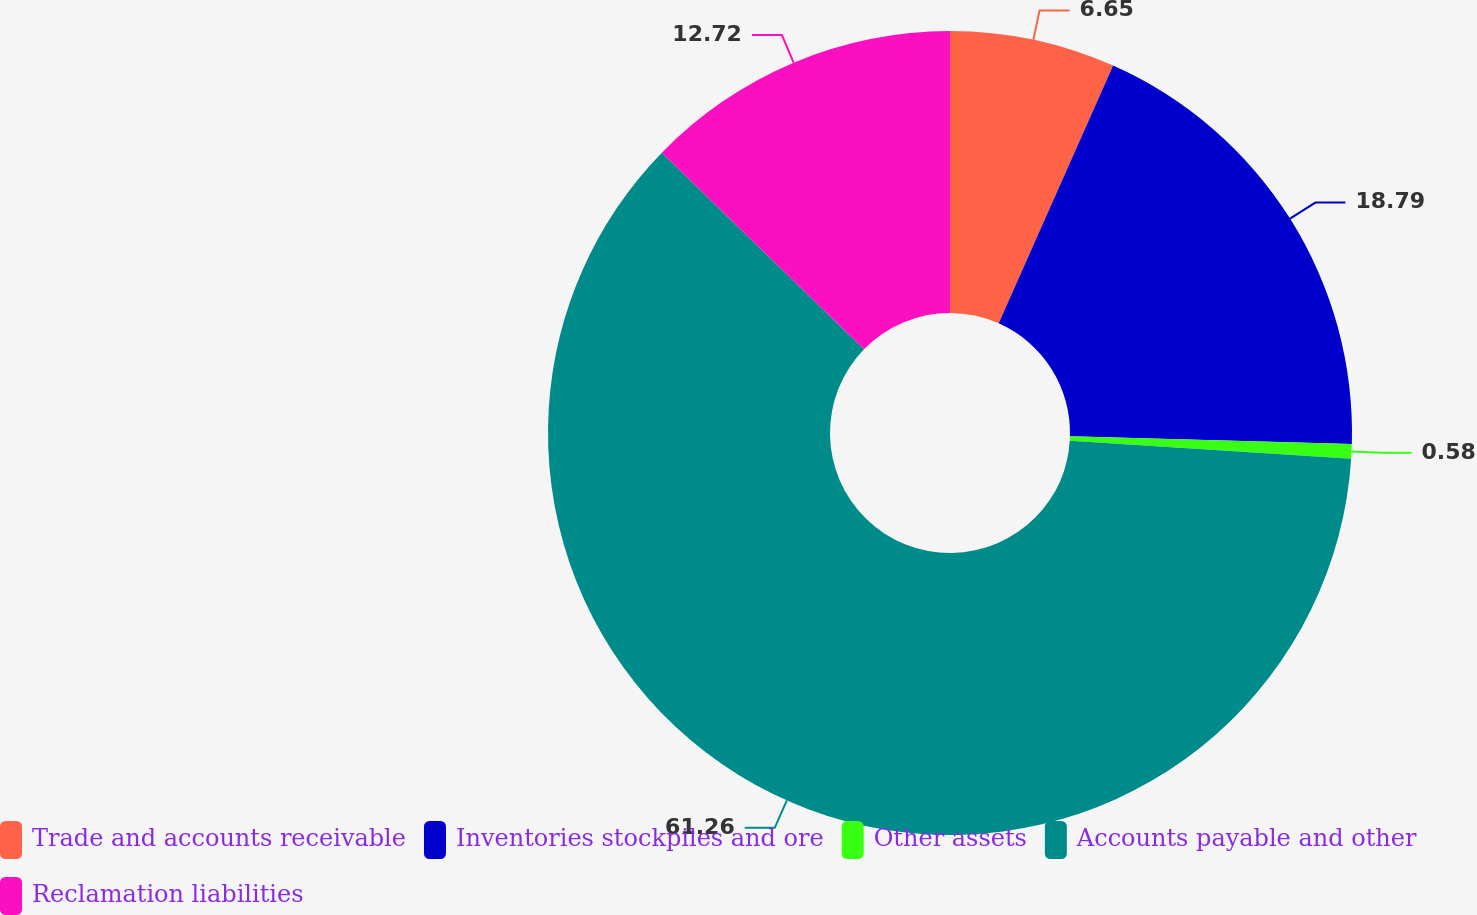Convert chart to OTSL. <chart><loc_0><loc_0><loc_500><loc_500><pie_chart><fcel>Trade and accounts receivable<fcel>Inventories stockpiles and ore<fcel>Other assets<fcel>Accounts payable and other<fcel>Reclamation liabilities<nl><fcel>6.65%<fcel>18.79%<fcel>0.58%<fcel>61.26%<fcel>12.72%<nl></chart> 